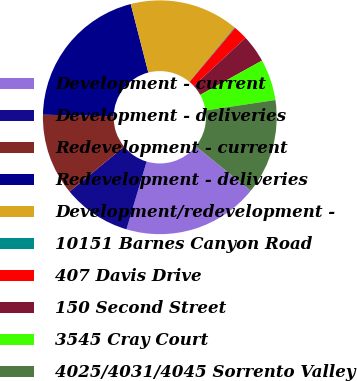Convert chart to OTSL. <chart><loc_0><loc_0><loc_500><loc_500><pie_chart><fcel>Development - current<fcel>Development - deliveries<fcel>Redevelopment - current<fcel>Redevelopment - deliveries<fcel>Development/redevelopment -<fcel>10151 Barnes Canyon Road<fcel>407 Davis Drive<fcel>150 Second Street<fcel>3545 Cray Court<fcel>4025/4031/4045 Sorrento Valley<nl><fcel>18.78%<fcel>9.44%<fcel>11.31%<fcel>20.65%<fcel>15.04%<fcel>0.1%<fcel>1.97%<fcel>3.83%<fcel>5.7%<fcel>13.18%<nl></chart> 